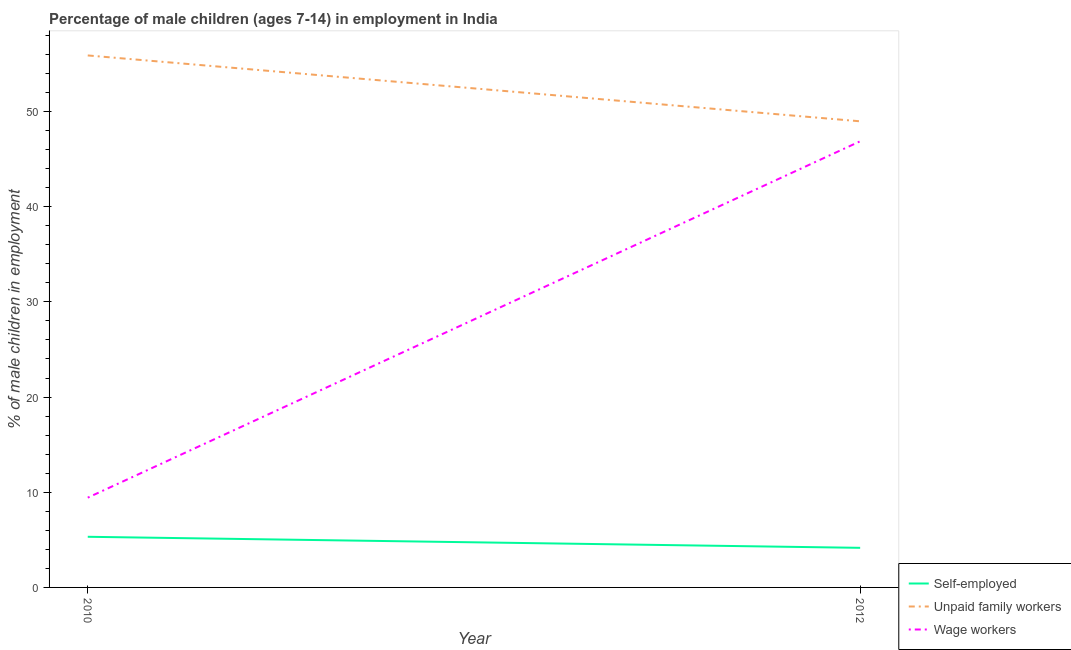What is the percentage of children employed as wage workers in 2010?
Provide a short and direct response. 9.43. Across all years, what is the maximum percentage of self employed children?
Give a very brief answer. 5.32. Across all years, what is the minimum percentage of self employed children?
Ensure brevity in your answer.  4.16. In which year was the percentage of children employed as wage workers maximum?
Offer a very short reply. 2012. In which year was the percentage of children employed as wage workers minimum?
Ensure brevity in your answer.  2010. What is the total percentage of self employed children in the graph?
Your answer should be compact. 9.48. What is the difference between the percentage of children employed as unpaid family workers in 2010 and that in 2012?
Offer a very short reply. 6.92. What is the difference between the percentage of children employed as unpaid family workers in 2012 and the percentage of children employed as wage workers in 2010?
Keep it short and to the point. 39.54. What is the average percentage of children employed as wage workers per year?
Keep it short and to the point. 28.15. In the year 2012, what is the difference between the percentage of children employed as wage workers and percentage of self employed children?
Offer a terse response. 42.71. What is the ratio of the percentage of self employed children in 2010 to that in 2012?
Ensure brevity in your answer.  1.28. Does the percentage of self employed children monotonically increase over the years?
Your answer should be compact. No. Is the percentage of children employed as unpaid family workers strictly greater than the percentage of children employed as wage workers over the years?
Your answer should be very brief. Yes. Is the percentage of self employed children strictly less than the percentage of children employed as unpaid family workers over the years?
Your answer should be very brief. Yes. What is the difference between two consecutive major ticks on the Y-axis?
Your answer should be very brief. 10. Are the values on the major ticks of Y-axis written in scientific E-notation?
Your answer should be very brief. No. Does the graph contain grids?
Your response must be concise. No. How are the legend labels stacked?
Ensure brevity in your answer.  Vertical. What is the title of the graph?
Keep it short and to the point. Percentage of male children (ages 7-14) in employment in India. Does "Slovak Republic" appear as one of the legend labels in the graph?
Ensure brevity in your answer.  No. What is the label or title of the X-axis?
Your response must be concise. Year. What is the label or title of the Y-axis?
Ensure brevity in your answer.  % of male children in employment. What is the % of male children in employment of Self-employed in 2010?
Your answer should be compact. 5.32. What is the % of male children in employment in Unpaid family workers in 2010?
Your answer should be compact. 55.89. What is the % of male children in employment in Wage workers in 2010?
Your response must be concise. 9.43. What is the % of male children in employment of Self-employed in 2012?
Provide a short and direct response. 4.16. What is the % of male children in employment in Unpaid family workers in 2012?
Ensure brevity in your answer.  48.97. What is the % of male children in employment in Wage workers in 2012?
Ensure brevity in your answer.  46.87. Across all years, what is the maximum % of male children in employment in Self-employed?
Ensure brevity in your answer.  5.32. Across all years, what is the maximum % of male children in employment in Unpaid family workers?
Provide a short and direct response. 55.89. Across all years, what is the maximum % of male children in employment of Wage workers?
Make the answer very short. 46.87. Across all years, what is the minimum % of male children in employment in Self-employed?
Provide a succinct answer. 4.16. Across all years, what is the minimum % of male children in employment in Unpaid family workers?
Offer a very short reply. 48.97. Across all years, what is the minimum % of male children in employment in Wage workers?
Your answer should be very brief. 9.43. What is the total % of male children in employment in Self-employed in the graph?
Your response must be concise. 9.48. What is the total % of male children in employment in Unpaid family workers in the graph?
Give a very brief answer. 104.86. What is the total % of male children in employment of Wage workers in the graph?
Provide a short and direct response. 56.3. What is the difference between the % of male children in employment in Self-employed in 2010 and that in 2012?
Your answer should be compact. 1.16. What is the difference between the % of male children in employment of Unpaid family workers in 2010 and that in 2012?
Offer a very short reply. 6.92. What is the difference between the % of male children in employment in Wage workers in 2010 and that in 2012?
Keep it short and to the point. -37.44. What is the difference between the % of male children in employment of Self-employed in 2010 and the % of male children in employment of Unpaid family workers in 2012?
Your answer should be very brief. -43.65. What is the difference between the % of male children in employment of Self-employed in 2010 and the % of male children in employment of Wage workers in 2012?
Your answer should be very brief. -41.55. What is the difference between the % of male children in employment in Unpaid family workers in 2010 and the % of male children in employment in Wage workers in 2012?
Provide a short and direct response. 9.02. What is the average % of male children in employment in Self-employed per year?
Provide a short and direct response. 4.74. What is the average % of male children in employment of Unpaid family workers per year?
Provide a short and direct response. 52.43. What is the average % of male children in employment in Wage workers per year?
Offer a terse response. 28.15. In the year 2010, what is the difference between the % of male children in employment in Self-employed and % of male children in employment in Unpaid family workers?
Ensure brevity in your answer.  -50.57. In the year 2010, what is the difference between the % of male children in employment in Self-employed and % of male children in employment in Wage workers?
Ensure brevity in your answer.  -4.11. In the year 2010, what is the difference between the % of male children in employment of Unpaid family workers and % of male children in employment of Wage workers?
Offer a terse response. 46.46. In the year 2012, what is the difference between the % of male children in employment of Self-employed and % of male children in employment of Unpaid family workers?
Offer a terse response. -44.81. In the year 2012, what is the difference between the % of male children in employment of Self-employed and % of male children in employment of Wage workers?
Provide a succinct answer. -42.71. What is the ratio of the % of male children in employment in Self-employed in 2010 to that in 2012?
Keep it short and to the point. 1.28. What is the ratio of the % of male children in employment in Unpaid family workers in 2010 to that in 2012?
Ensure brevity in your answer.  1.14. What is the ratio of the % of male children in employment of Wage workers in 2010 to that in 2012?
Ensure brevity in your answer.  0.2. What is the difference between the highest and the second highest % of male children in employment of Self-employed?
Provide a short and direct response. 1.16. What is the difference between the highest and the second highest % of male children in employment of Unpaid family workers?
Your answer should be very brief. 6.92. What is the difference between the highest and the second highest % of male children in employment in Wage workers?
Offer a very short reply. 37.44. What is the difference between the highest and the lowest % of male children in employment of Self-employed?
Make the answer very short. 1.16. What is the difference between the highest and the lowest % of male children in employment of Unpaid family workers?
Provide a short and direct response. 6.92. What is the difference between the highest and the lowest % of male children in employment of Wage workers?
Your answer should be compact. 37.44. 